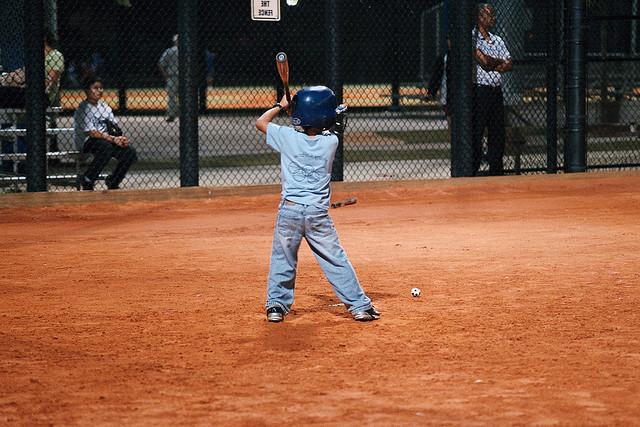What color is the child's shirt?
Answer briefly. Blue. Which team is winning?
Write a very short answer. Blue team. Is this the most common stance for a battery?
Concise answer only. Yes. Why is this child wearing a helmet?
Be succinct. Protection. Does the weather appear sunny?
Quick response, please. No. Is this child warming up?
Answer briefly. No. 